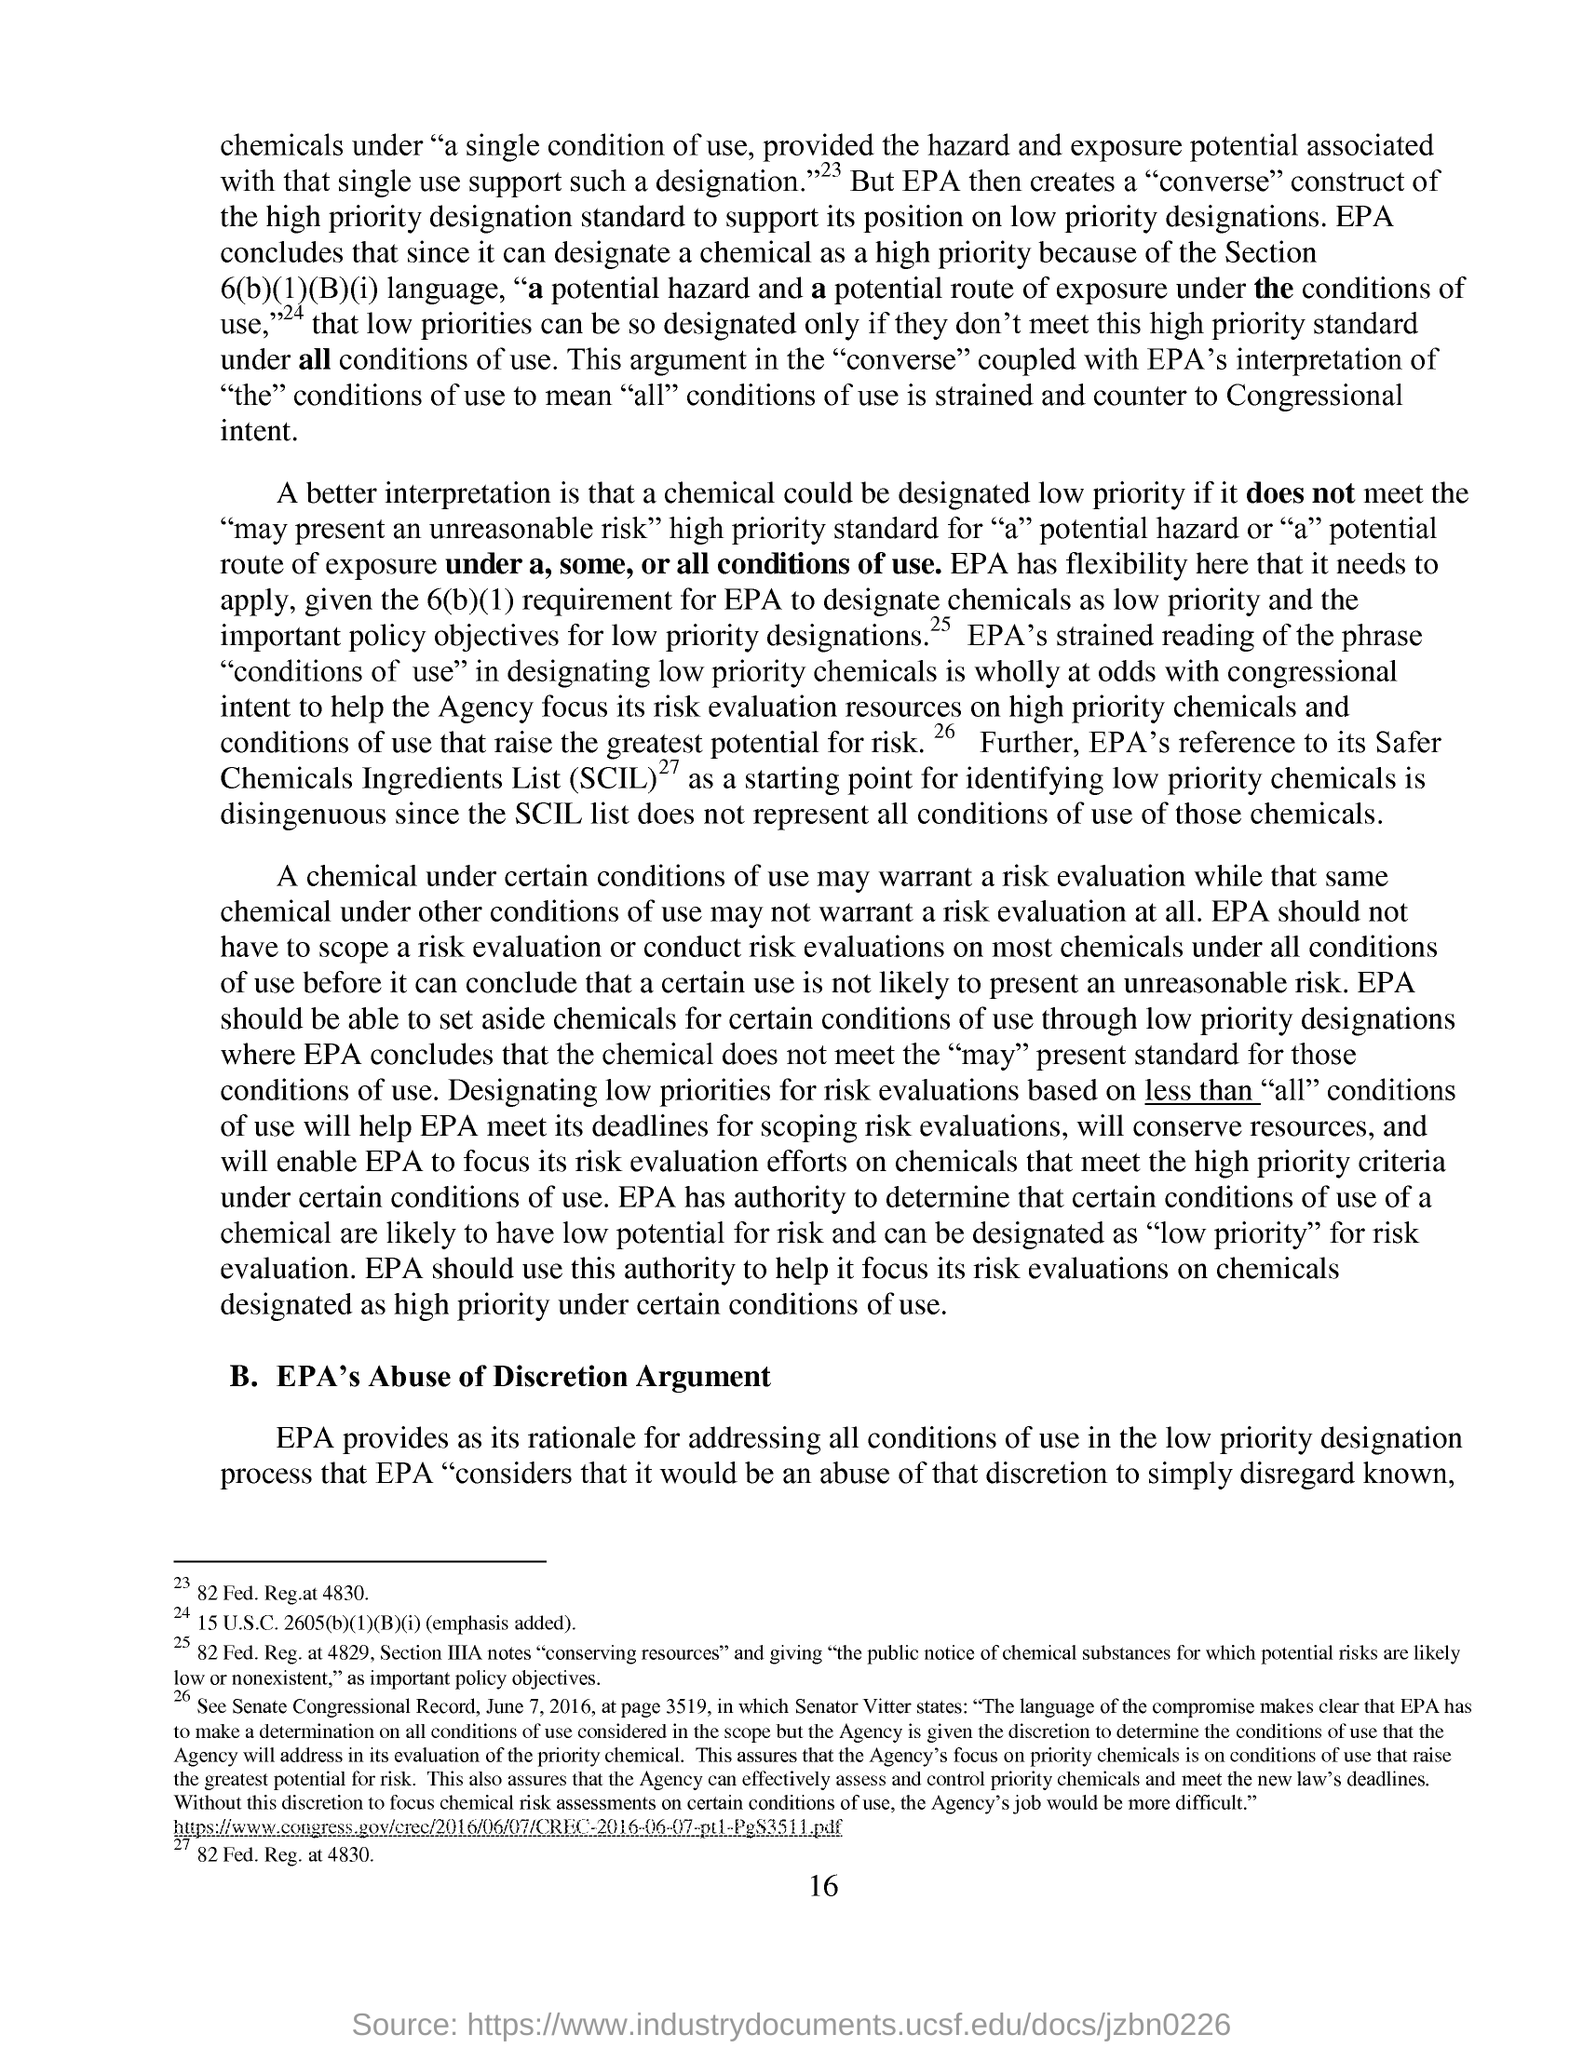Draw attention to some important aspects in this diagram. The full form of SCIL is Safer Chemicals Ingredients List. The subheading in this document is 'EPA's Abuse of Discretion Argument.' The page number mentioned in this document is 16. The Environmental Protection Agency (EPA) has the authority to designate a chemical as a high priority. 